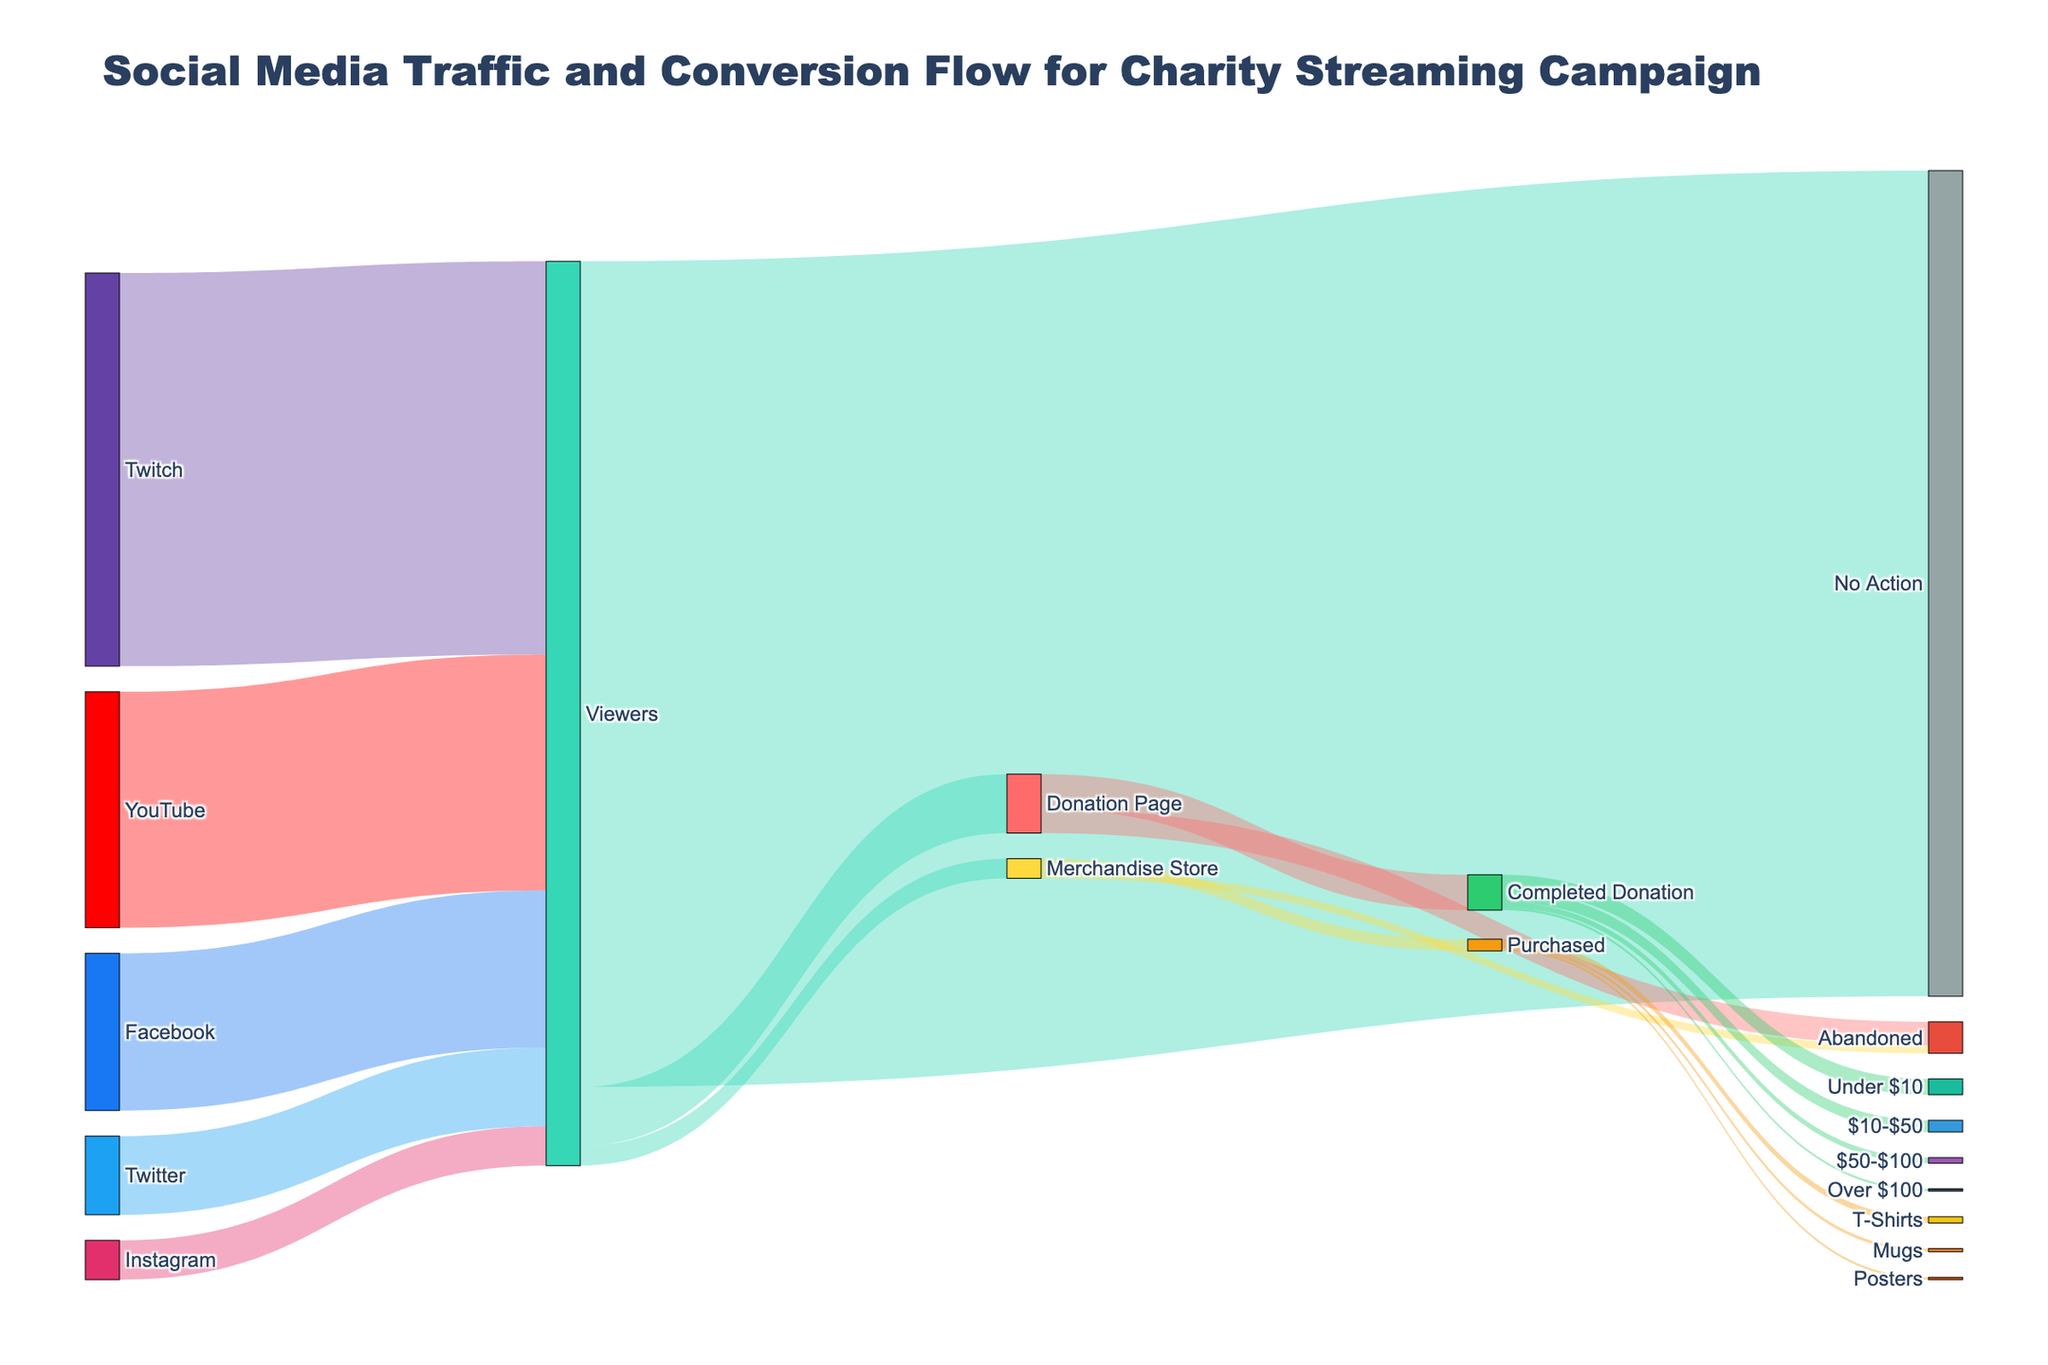What's the total number of viewers from all social media sources? To determine the total number of viewers, sum up the values from all the social media sources: 500000 (Twitch) + 300000 (YouTube) + 200000 (Facebook) + 100000 (Twitter) + 50000 (Instagram) = 1150000 viewers.
Answer: 1150000 Which social media platform contributed the most viewers to the campaign? Identify the source with the highest value among the social media platforms: Twitch (500000), YouTube (300000), Facebook (200000), Twitter (100000), Instagram (50000). Twitch has the highest value.
Answer: Twitch What percentage of viewers took no action after watching the campaign? First, find the total number of viewers (1150000) and the number of viewers who took no action (1050000). Then, calculate the percentage: (1050000 / 1150000) * 100 = 91.3%.
Answer: 91.3% How many viewers proceeded to the Donation Page, and how many completed a donation? The number of viewers who went to the Donation Page is shown as a flow from Viewers to Donation Page (75000). Out of these, those who completed the donation is shown as a flow from Donation Page to Completed Donation (45000). So, 75000 went to the Donation Page, and 45000 completed the donation.
Answer: 75000, 45000 What is the total number of viewers who either donated or purchased merchandise? Sum the values of viewers who went to the Donation Page and Merchandise Store: 75000 (Donation Page) + 25000 (Merchandise Store) = 100000.
Answer: 100000 What proportion of completed donations were under $10? From the Completed Donation node (45000), identify the flow going to Under $10 (20000). Calculate the proportion: 20000 / 45000 = 0.4444 or 44.44%.
Answer: 44.44% Out of the viewers who visited the Merchandise Store, how many ended up purchasing something? From the Merchandise Store node (25000), identify the flow going to Purchased (15000).
Answer: 15000 Which item had the highest sale in the Merchandise Store? Compare the values flowing from Purchased to T-Shirts (8000), Mugs (4000), and Posters (3000). T-Shirts have the highest value.
Answer: T-Shirts What percentage of people who visited the Donation Page abandoned the process? From the Donation Page node (75000), identify the flow going to Abandoned (30000). Calculate the percentage: (30000 / 75000) * 100 = 40%.
Answer: 40% How does the traffic from YouTube viewers compare to Facebook viewers? Compare the values of viewers from YouTube (300000) to those from Facebook (200000). YouTube has 100000 more viewers than Facebook.
Answer: YouTube has 100000 more viewers than Facebook 